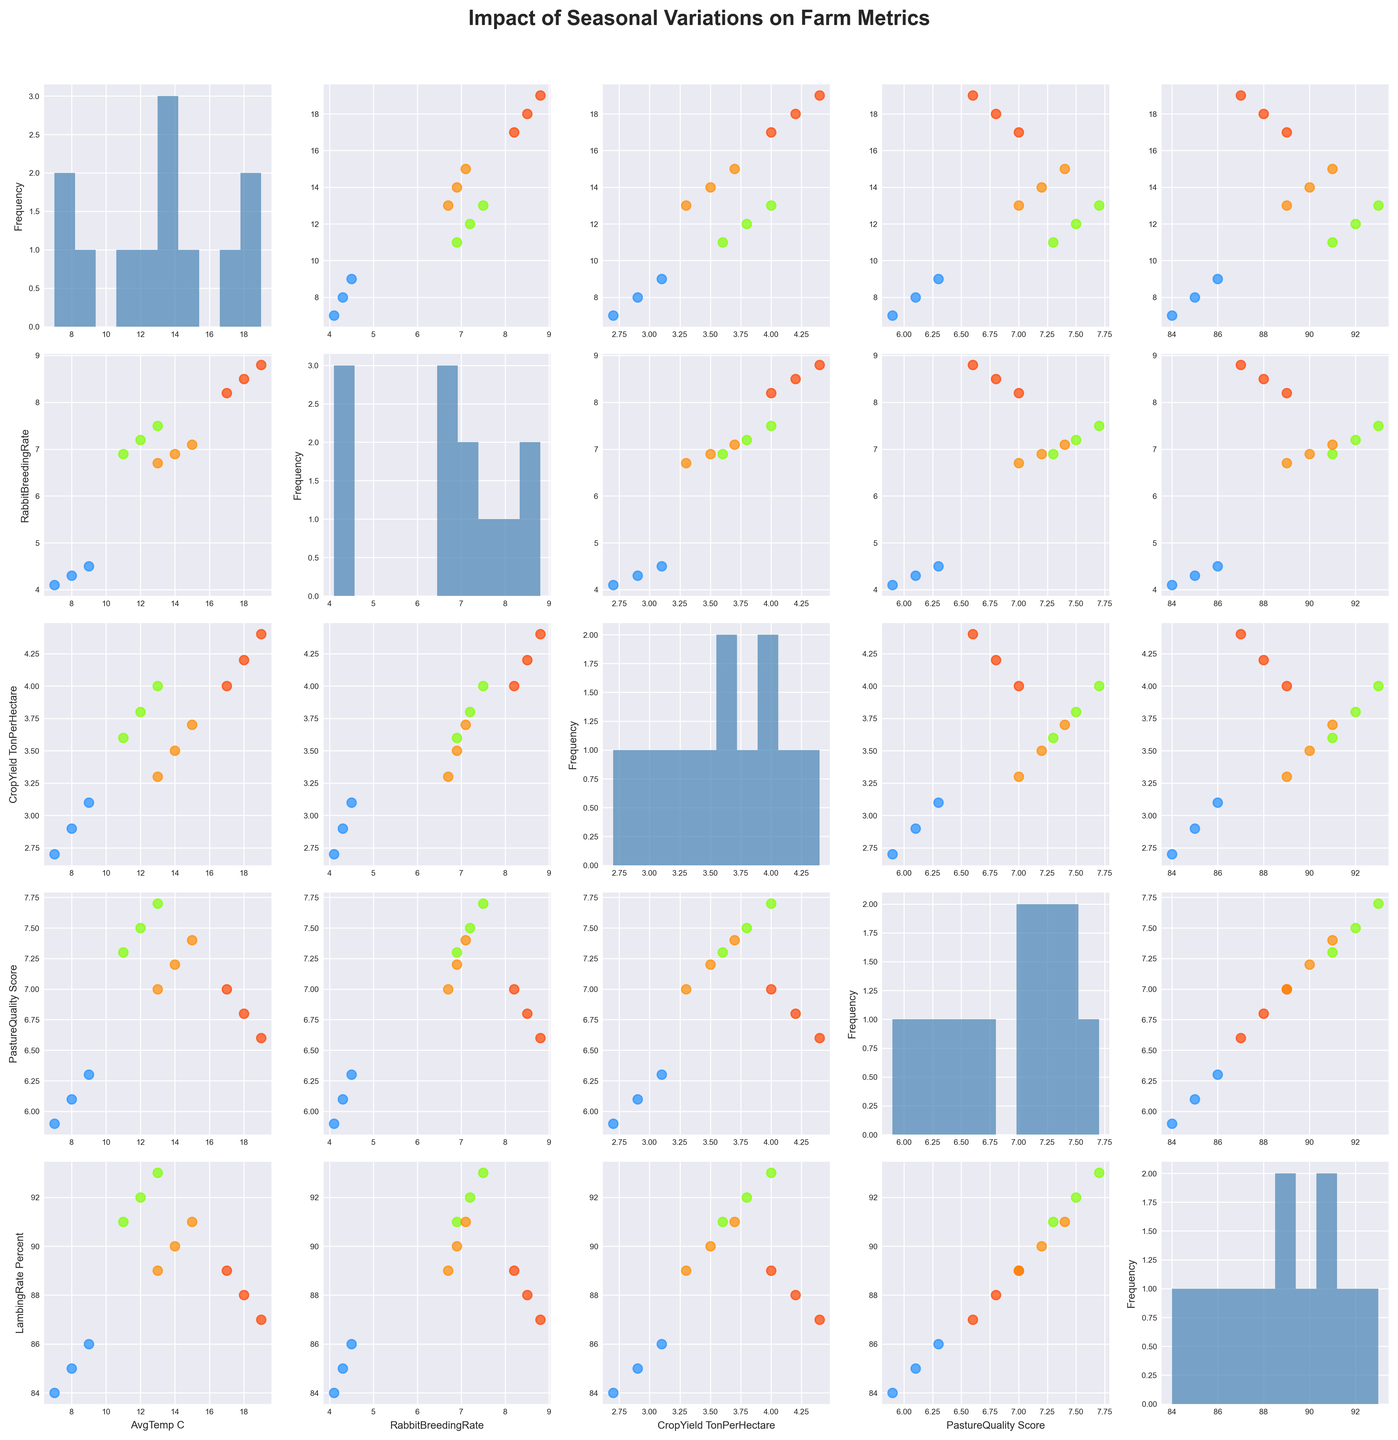What is the color used to represent data points for each season? The data points for each season are represented by different colors. The scatterplot matrix legend clarifies: Spring uses light green, Summer uses red-orange, Autumn uses orange, and Winter uses bright blue.
Answer: Spring: light green, Summer: red-orange, Autumn: orange, Winter: bright blue What is the title of the scatterplot matrix? The title of the scatterplot matrix is prominently displayed at the top of the figure in bold letters. It reads "Impact of Seasonal Variations on Farm Metrics."
Answer: Impact of Seasonal Variations on Farm Metrics Which season has the highest average Rabbit Breeding Rate, and what is that rate? By examining the scatterplots, Summer consistently appears at the higher end of the Rabbit Breeding Rate axis across different temperature ranges. The specific rate can be confirmed by seeing the data points in the Summer color (red-orange) reaching the highest values.
Answer: Summer, 8.8 How does the Crop Yield in Summer compare to Winter? Observing the scatterplots for Crop Yield versus average temperature or other factors across seasons, Summer data points (red-orange) generally show higher values compared to Winter (bright blue).
Answer: Summer is higher During which season does the highest Lambing Rate occur? From the scatterplots, by comparing the vertical and horizontal positions of the data points by seasons, Spring (light green) shows the highest Lambing Rate value close to 93 percent.
Answer: Spring Is there a general trend in Rabbit Breeding Rate with increasing average temperature? Comparing Rabbit Breeding Rate across the scatterplots against AvgTemp_C, data points tend to generally increase as the average temperature rises, indicating a positive correlation.
Answer: Increases with temperature What is the frequency of the different Rabbit Breeding Rates? Looking at the histograms on the diagonal corresponding to Rabbit Breeding Rate, the frequency of the Rabbit Breeding Rates can be observed. Most frequent rates seem to cluster around 7.0-8.5.
Answer: 7.0-8.5 most frequent Which season shows the lowest Pasture Quality Score, and what is that score? By identifying the scatter plots that show Pasture Quality Score on one of the axes, we can see that Winter (bright blue) data points span to the lowest value around 5.9.
Answer: Winter, 5.9 What is the range of Crop Yield values seen across all seasons? The histogram on the diagonal for Crop Yield displays the distribution, indicating a range approximately from 2.7 to 4.4 tons per hectare.
Answer: 2.7 to 4.4 How do Lambing Rate percentages compare between Spring and Autumn? Comparing data points for Spring (light green) and Autumn (orange) in the scatterplots with Lambing Rate, Spring tends to have slightly higher values around 92-93%, whereas Autumn clusters around 90-91%.
Answer: Spring is higher 